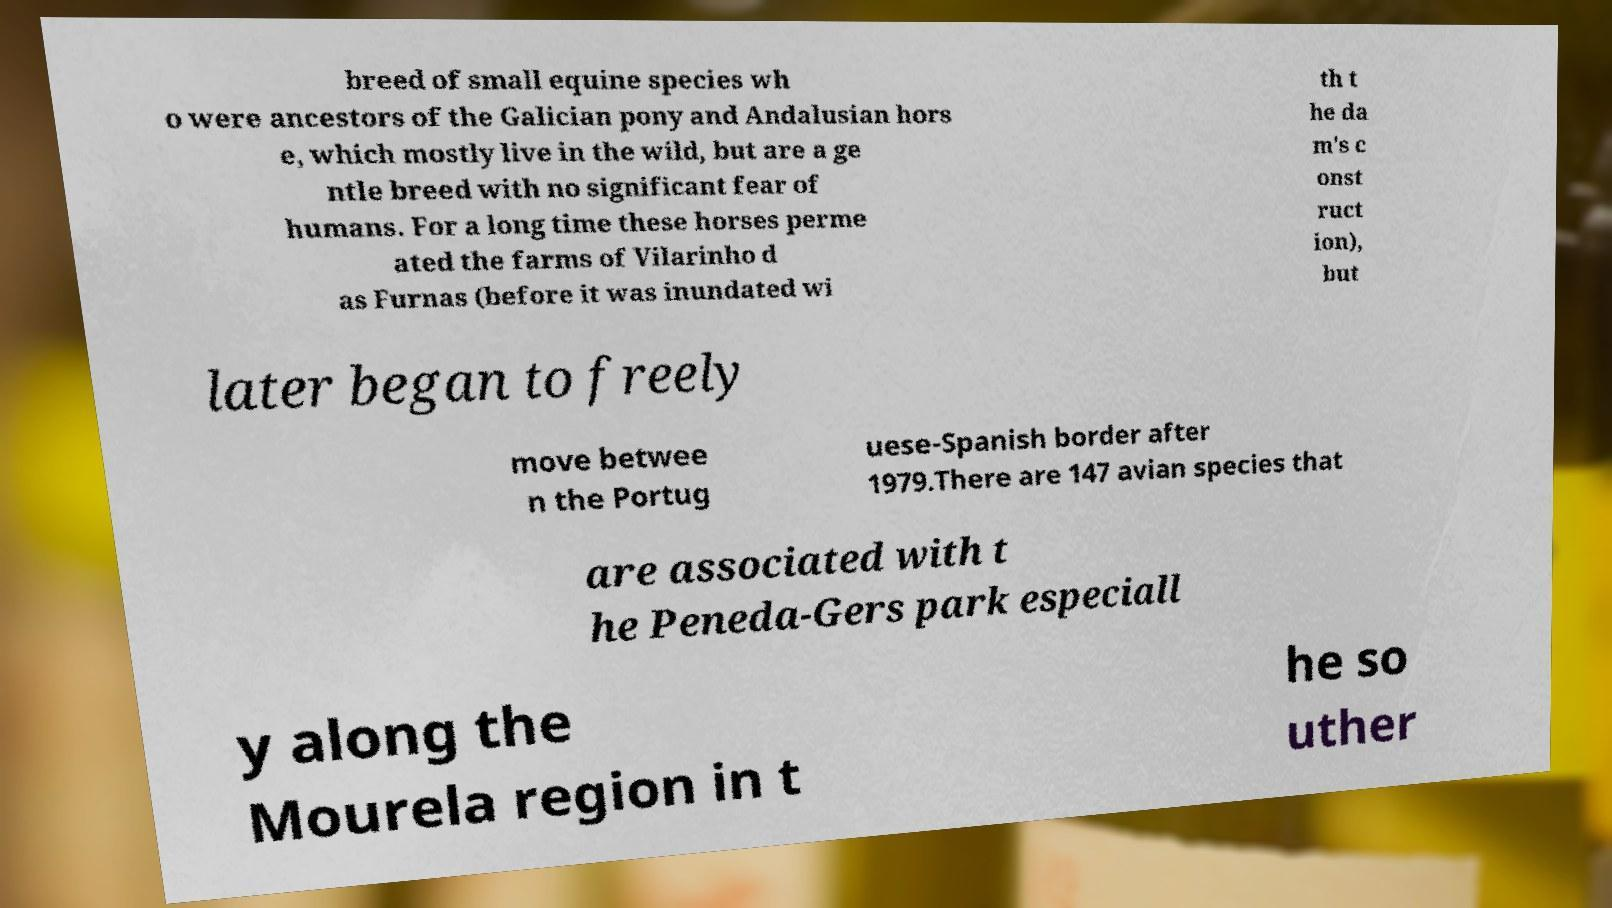Please identify and transcribe the text found in this image. breed of small equine species wh o were ancestors of the Galician pony and Andalusian hors e, which mostly live in the wild, but are a ge ntle breed with no significant fear of humans. For a long time these horses perme ated the farms of Vilarinho d as Furnas (before it was inundated wi th t he da m's c onst ruct ion), but later began to freely move betwee n the Portug uese-Spanish border after 1979.There are 147 avian species that are associated with t he Peneda-Gers park especiall y along the Mourela region in t he so uther 